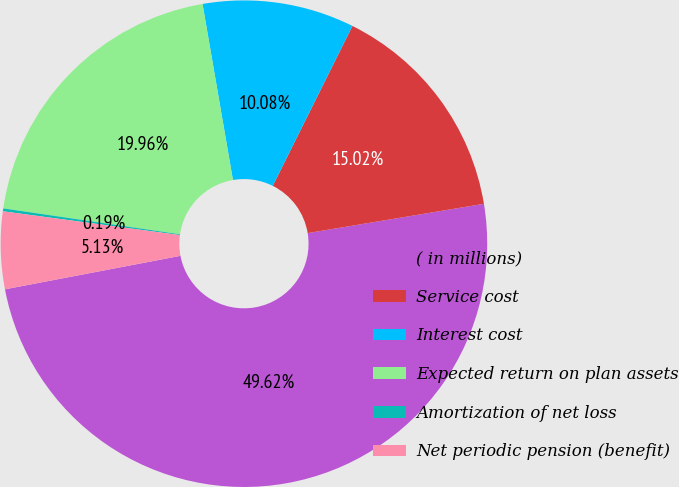<chart> <loc_0><loc_0><loc_500><loc_500><pie_chart><fcel>( in millions)<fcel>Service cost<fcel>Interest cost<fcel>Expected return on plan assets<fcel>Amortization of net loss<fcel>Net periodic pension (benefit)<nl><fcel>49.62%<fcel>15.02%<fcel>10.08%<fcel>19.96%<fcel>0.19%<fcel>5.13%<nl></chart> 